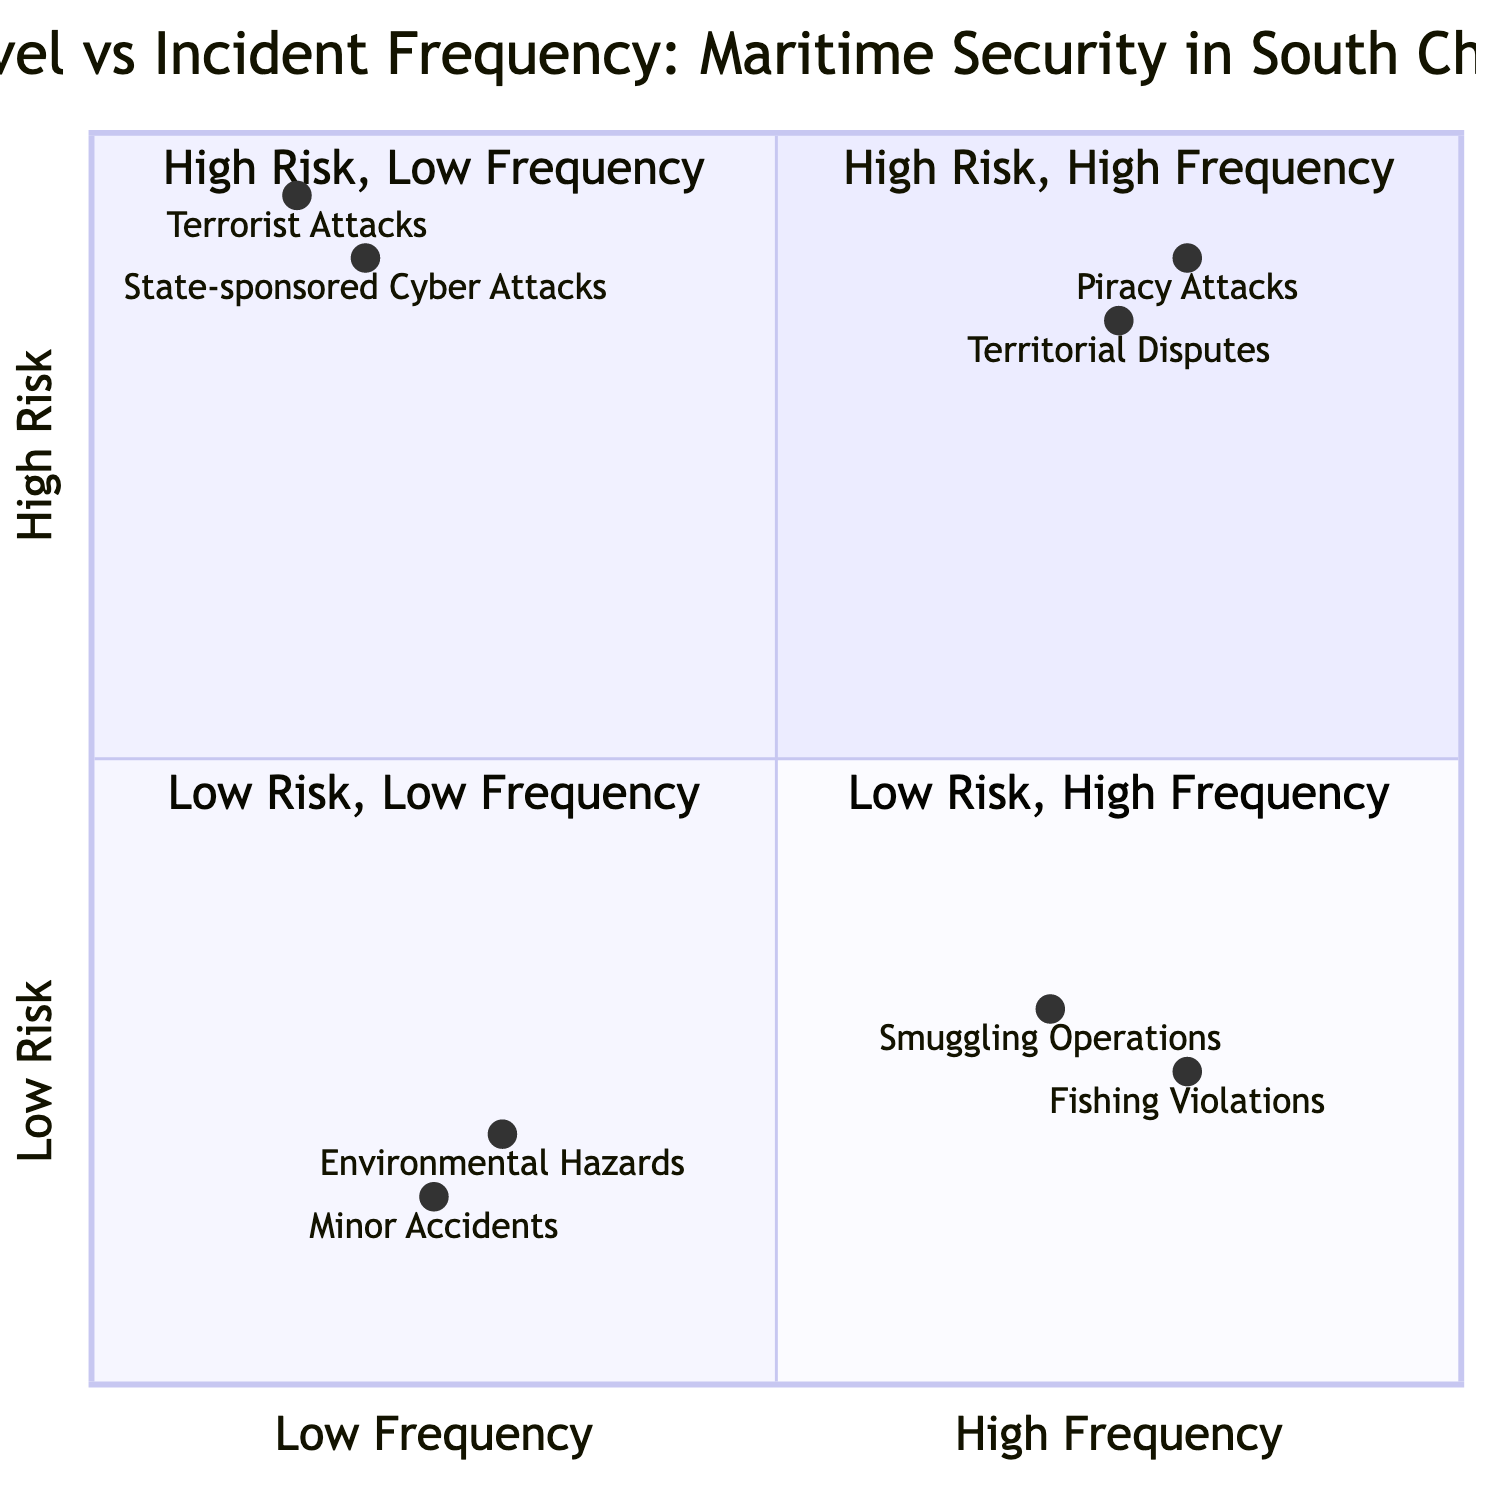What incidents are categorized under High Risk, High Frequency? The quadrant labeled "High Risk, High Frequency" includes "Piracy Attacks" and "Territorial Disputes." These incidents are marked by their high likelihood and potential danger.
Answer: Piracy Attacks, Territorial Disputes Which incident has the highest risk level according to the diagram? By reviewing the quadrants, "Piracy Attacks" are located highest in the "Risk Level" axis compared to others, indicating they are of the highest concern.
Answer: Piracy Attacks What is the incident frequency of the "Environmental Hazards"? The location of "Environmental Hazards" in the quadrant chart is represented in the Low Frequency area, indicating that such events do not occur often.
Answer: Low Frequency How many incidents are classified as High Risk, Low Frequency? There are two incidents marked in the quadrant "High Risk, Low Frequency," specifically "State-sponsored Cyber Attacks" and "Terrorist Attacks." This means there’s a total of two incidents in this classification.
Answer: 2 Which incident has a lower risk than "Fishing Violations"? Evaluating the risk labels, "Environmental Hazards" and "Minor Accidents" are below "Fishing Violations," indicating they are of lesser risk.
Answer: Environmental Hazards, Minor Accidents What is the overall relationship between frequency and risk level in this chart? On this quadrant chart, it can be seen that as risk level increases, the frequency tends to decrease for certain incidents, while several incidents fall in high frequency despite varying risks.
Answer: Frequency decreases with increasing risk Which quadrant contains incidents that experience Low Risk but High Frequency? The quadrant labeled "Low Risk, High Frequency" includes incidents such as "Smuggling Operations" and "Fishing Violations." This classification reflects those incidents that occur often but are not highly risky.
Answer: Smuggling Operations, Fishing Violations Name one specific example of "Terrorist Attacks" listed in the chart. The chart provides "SuperFerry 14 Bombing" as a documented incident under the "Terrorist Attacks" category, signifying a notable case within this classification.
Answer: SuperFerry 14 Bombing 